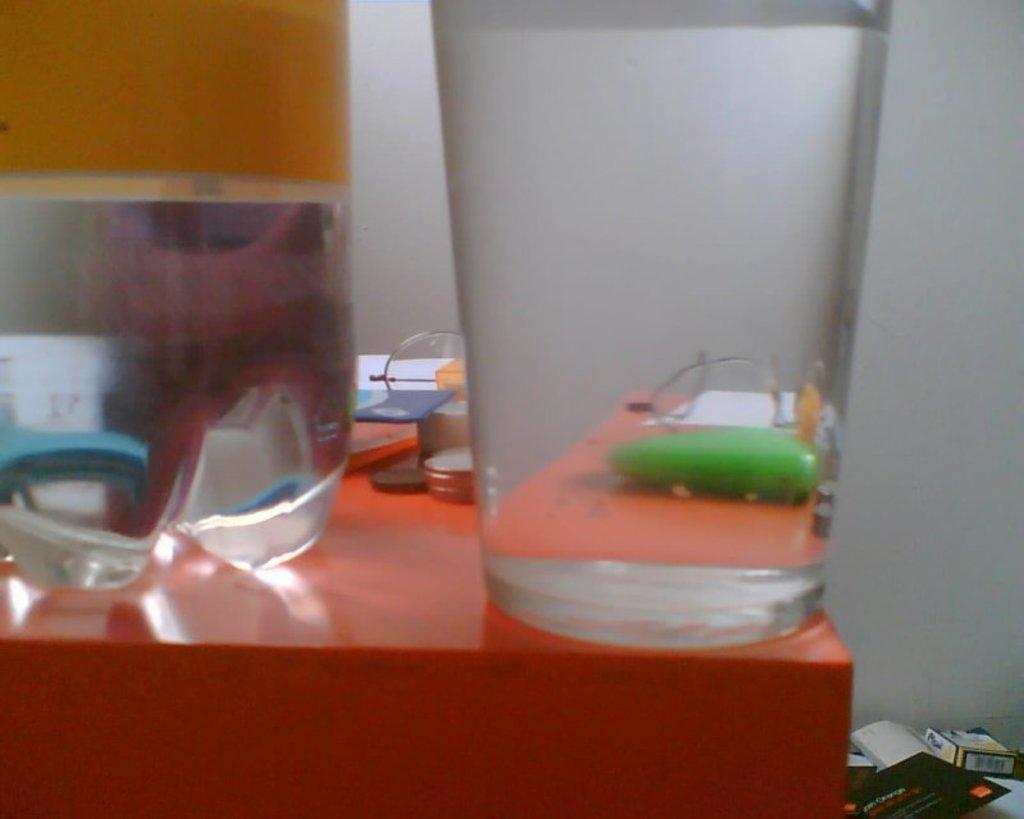Could you give a brief overview of what you see in this image? In the picture there is one glass and one water bottle and some things on the desk and at the right corner there are books and behind that there is a wall. 